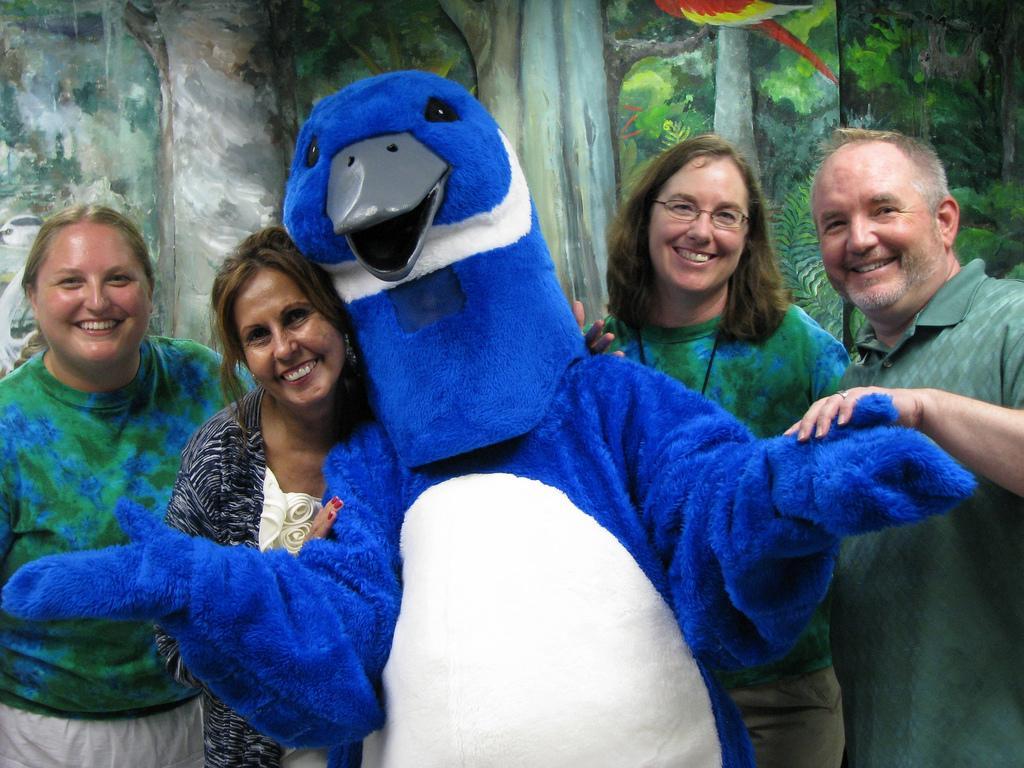Could you give a brief overview of what you see in this image? In this picture I can see a person wearing the costume. I can see a few people with a smile. I can see the painting in the background. 